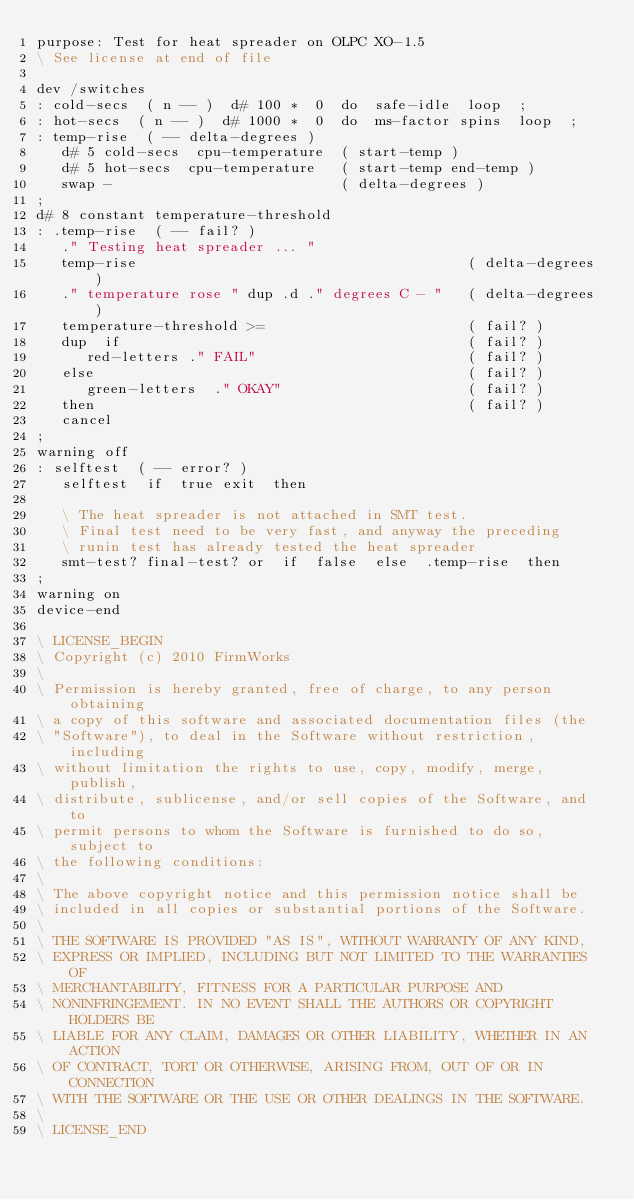Convert code to text. <code><loc_0><loc_0><loc_500><loc_500><_Forth_>purpose: Test for heat spreader on OLPC XO-1.5
\ See license at end of file

dev /switches
: cold-secs  ( n -- )  d# 100 *  0  do  safe-idle  loop  ;
: hot-secs  ( n -- )  d# 1000 *  0  do  ms-factor spins  loop  ;
: temp-rise  ( -- delta-degrees )
   d# 5 cold-secs  cpu-temperature  ( start-temp )
   d# 5 hot-secs  cpu-temperature   ( start-temp end-temp )
   swap -                           ( delta-degrees )
;
d# 8 constant temperature-threshold
: .temp-rise  ( -- fail? )
   ." Testing heat spreader ... "
   temp-rise                                       ( delta-degrees )
   ." temperature rose " dup .d ." degrees C - "   ( delta-degrees )
   temperature-threshold >=                        ( fail? )
   dup  if                                         ( fail? )
      red-letters ." FAIL"                         ( fail? )
   else                                            ( fail? )
      green-letters  ." OKAY"                      ( fail? )
   then                                            ( fail? )
   cancel
;
warning off
: selftest  ( -- error? )
   selftest  if  true exit  then

   \ The heat spreader is not attached in SMT test.
   \ Final test need to be very fast, and anyway the preceding
   \ runin test has already tested the heat spreader
   smt-test? final-test? or  if  false  else  .temp-rise  then
;
warning on
device-end

\ LICENSE_BEGIN
\ Copyright (c) 2010 FirmWorks
\ 
\ Permission is hereby granted, free of charge, to any person obtaining
\ a copy of this software and associated documentation files (the
\ "Software"), to deal in the Software without restriction, including
\ without limitation the rights to use, copy, modify, merge, publish,
\ distribute, sublicense, and/or sell copies of the Software, and to
\ permit persons to whom the Software is furnished to do so, subject to
\ the following conditions:
\ 
\ The above copyright notice and this permission notice shall be
\ included in all copies or substantial portions of the Software.
\ 
\ THE SOFTWARE IS PROVIDED "AS IS", WITHOUT WARRANTY OF ANY KIND,
\ EXPRESS OR IMPLIED, INCLUDING BUT NOT LIMITED TO THE WARRANTIES OF
\ MERCHANTABILITY, FITNESS FOR A PARTICULAR PURPOSE AND
\ NONINFRINGEMENT. IN NO EVENT SHALL THE AUTHORS OR COPYRIGHT HOLDERS BE
\ LIABLE FOR ANY CLAIM, DAMAGES OR OTHER LIABILITY, WHETHER IN AN ACTION
\ OF CONTRACT, TORT OR OTHERWISE, ARISING FROM, OUT OF OR IN CONNECTION
\ WITH THE SOFTWARE OR THE USE OR OTHER DEALINGS IN THE SOFTWARE.
\
\ LICENSE_END
</code> 